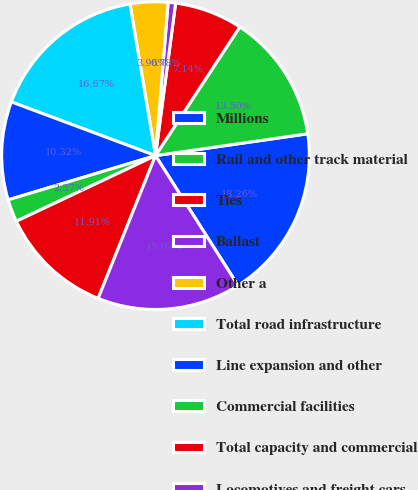<chart> <loc_0><loc_0><loc_500><loc_500><pie_chart><fcel>Millions<fcel>Rail and other track material<fcel>Ties<fcel>Ballast<fcel>Other a<fcel>Total road infrastructure<fcel>Line expansion and other<fcel>Commercial facilities<fcel>Total capacity and commercial<fcel>Locomotives and freight cars<nl><fcel>18.26%<fcel>13.5%<fcel>7.14%<fcel>0.78%<fcel>3.96%<fcel>16.67%<fcel>10.32%<fcel>2.37%<fcel>11.91%<fcel>15.09%<nl></chart> 